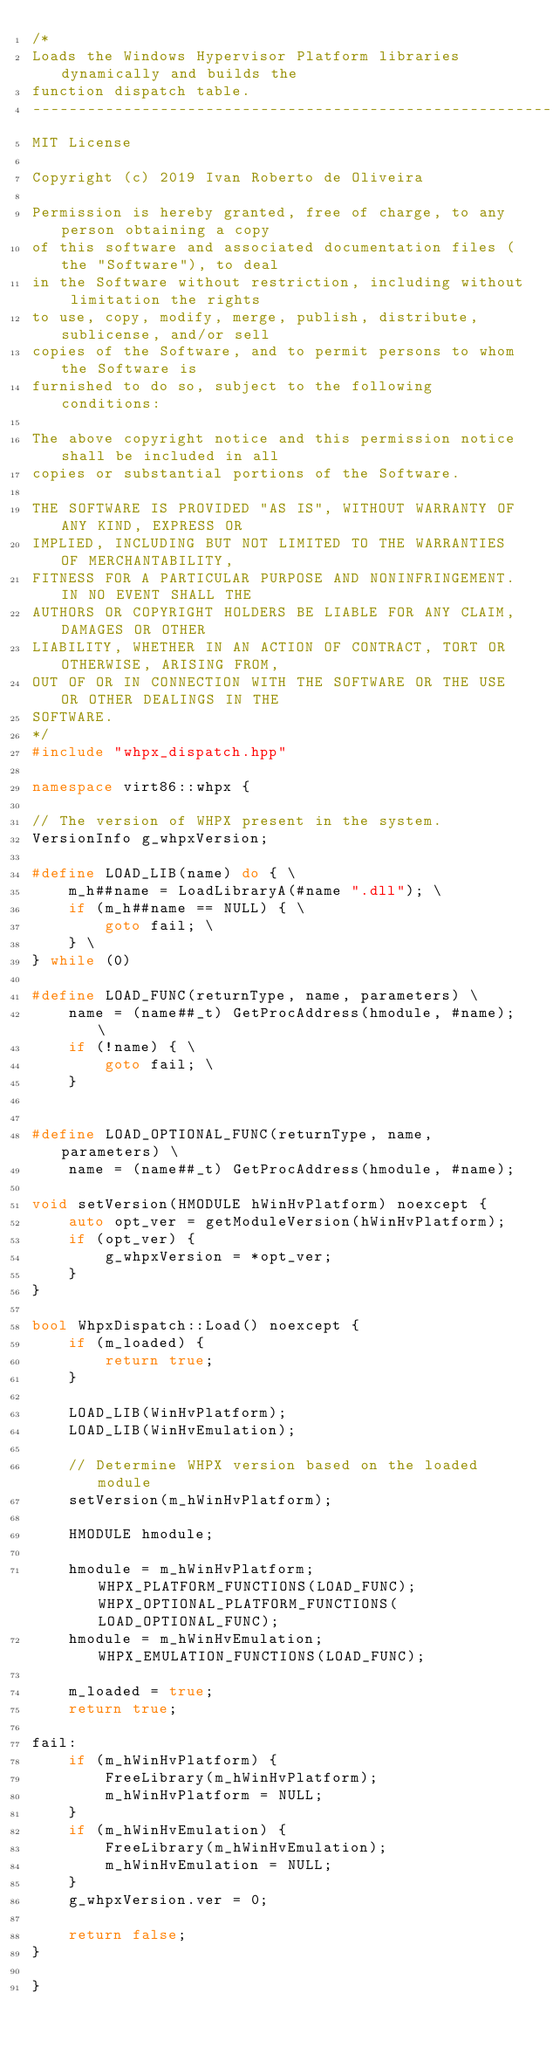Convert code to text. <code><loc_0><loc_0><loc_500><loc_500><_C++_>/*
Loads the Windows Hypervisor Platform libraries dynamically and builds the
function dispatch table.
-------------------------------------------------------------------------------
MIT License

Copyright (c) 2019 Ivan Roberto de Oliveira

Permission is hereby granted, free of charge, to any person obtaining a copy
of this software and associated documentation files (the "Software"), to deal
in the Software without restriction, including without limitation the rights
to use, copy, modify, merge, publish, distribute, sublicense, and/or sell
copies of the Software, and to permit persons to whom the Software is
furnished to do so, subject to the following conditions:

The above copyright notice and this permission notice shall be included in all
copies or substantial portions of the Software.

THE SOFTWARE IS PROVIDED "AS IS", WITHOUT WARRANTY OF ANY KIND, EXPRESS OR
IMPLIED, INCLUDING BUT NOT LIMITED TO THE WARRANTIES OF MERCHANTABILITY,
FITNESS FOR A PARTICULAR PURPOSE AND NONINFRINGEMENT. IN NO EVENT SHALL THE
AUTHORS OR COPYRIGHT HOLDERS BE LIABLE FOR ANY CLAIM, DAMAGES OR OTHER
LIABILITY, WHETHER IN AN ACTION OF CONTRACT, TORT OR OTHERWISE, ARISING FROM,
OUT OF OR IN CONNECTION WITH THE SOFTWARE OR THE USE OR OTHER DEALINGS IN THE
SOFTWARE.
*/
#include "whpx_dispatch.hpp"

namespace virt86::whpx {

// The version of WHPX present in the system.
VersionInfo g_whpxVersion;

#define LOAD_LIB(name) do { \
    m_h##name = LoadLibraryA(#name ".dll"); \
    if (m_h##name == NULL) { \
        goto fail; \
    } \
} while (0)

#define LOAD_FUNC(returnType, name, parameters) \
    name = (name##_t) GetProcAddress(hmodule, #name); \
    if (!name) { \
        goto fail; \
    }


#define LOAD_OPTIONAL_FUNC(returnType, name, parameters) \
    name = (name##_t) GetProcAddress(hmodule, #name);

void setVersion(HMODULE hWinHvPlatform) noexcept {
    auto opt_ver = getModuleVersion(hWinHvPlatform);
    if (opt_ver) {
        g_whpxVersion = *opt_ver;
    }
}

bool WhpxDispatch::Load() noexcept {
    if (m_loaded) {
        return true;
    }
    
    LOAD_LIB(WinHvPlatform);
    LOAD_LIB(WinHvEmulation);

    // Determine WHPX version based on the loaded module
    setVersion(m_hWinHvPlatform);

    HMODULE hmodule;

    hmodule = m_hWinHvPlatform; WHPX_PLATFORM_FUNCTIONS(LOAD_FUNC); WHPX_OPTIONAL_PLATFORM_FUNCTIONS(LOAD_OPTIONAL_FUNC);
    hmodule = m_hWinHvEmulation; WHPX_EMULATION_FUNCTIONS(LOAD_FUNC);

    m_loaded = true;
    return true;

fail:
    if (m_hWinHvPlatform) {
        FreeLibrary(m_hWinHvPlatform);
        m_hWinHvPlatform = NULL;
    }
    if (m_hWinHvEmulation) {
        FreeLibrary(m_hWinHvEmulation);
        m_hWinHvEmulation = NULL;
    }
    g_whpxVersion.ver = 0;

    return false;
}

}
</code> 